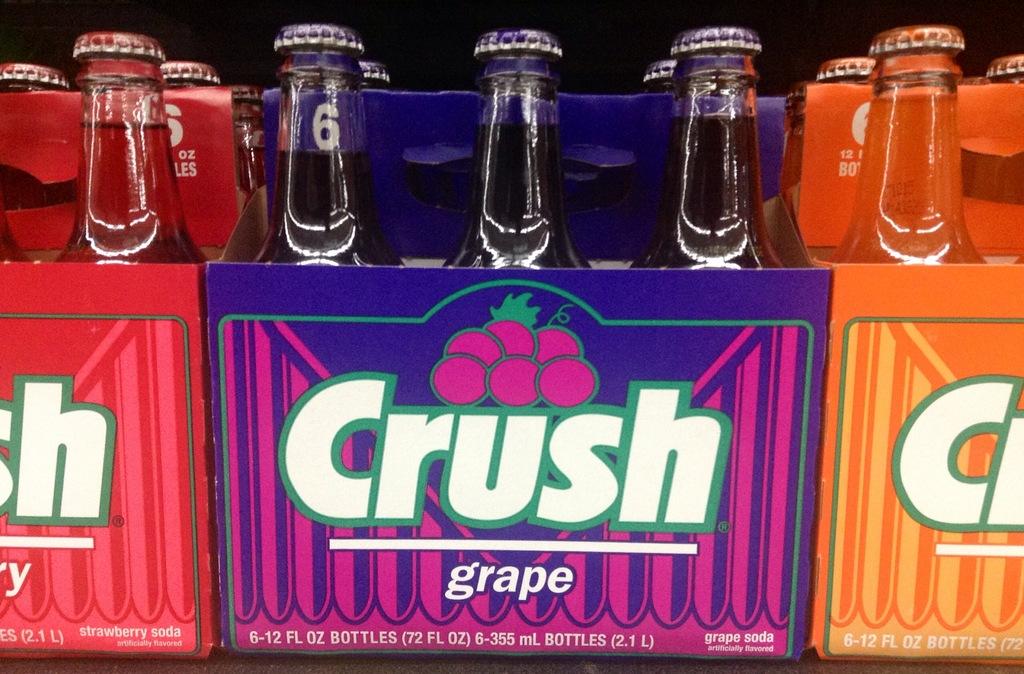What flavor is the purple soda?
Make the answer very short. Grape. What brand of soda is this?
Provide a short and direct response. Crush. 